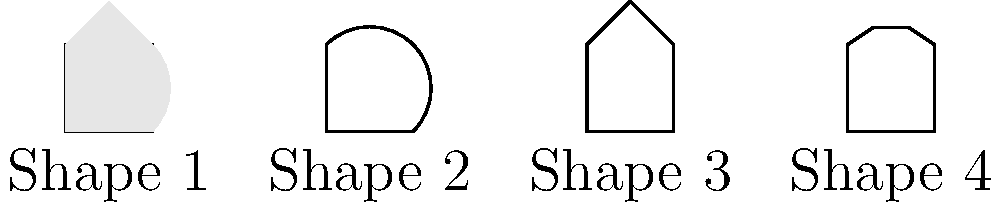As an editor of a linguistics journal, you are reviewing a submission on sign language hand shape classification. The article proposes a machine learning model to classify four basic hand shapes in sign language images. Which of the hand shapes shown above would likely be the most challenging for the model to distinguish from the others, and why? To answer this question, we need to consider the characteristics of each hand shape and how they might be perceived by a machine learning model:

1. Shape 1 (Closed fist): This shape has a distinct square outline with no protruding fingers.
2. Shape 2 (Open hand): This shape has a rounded outline, clearly different from the others.
3. Shape 3 (Pointing index finger): This shape has a distinct triangular protrusion at the top.
4. Shape 4 (V-shape): This shape has two small protrusions at the top.

The most challenging shape for the model to distinguish would likely be Shape 4 (V-shape) for the following reasons:

1. Similarity to other shapes: The V-shape could be mistaken for the pointing index finger (Shape 3) if one of the protrusions is not clearly visible or if the image quality is poor.

2. Variability in execution: The V-shape can vary significantly depending on the angle of the fingers and the perspective of the image, making it harder to consistently identify.

3. Potential for occlusion: In real-world signing, the V-shape might be partially obscured by other parts of the body or by motion blur, making it harder to distinguish from a pointing finger or even an open hand.

4. Subtle differences: The distinction between the V-shape and other shapes (especially the pointing finger) relies on detecting relatively small features (the two protrusions), which may be challenging for the model to consistently identify across various lighting conditions and image qualities.

5. Context dependency: In some sign languages, the V-shape and pointing finger may be used in similar contexts, potentially leading to confusion if the model doesn't account for additional contextual cues.

These factors combined make Shape 4 (V-shape) the most likely to present challenges for the machine learning model in consistently and accurately classifying it among the four basic hand shapes.
Answer: Shape 4 (V-shape) 